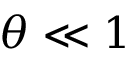<formula> <loc_0><loc_0><loc_500><loc_500>\theta \ll 1</formula> 